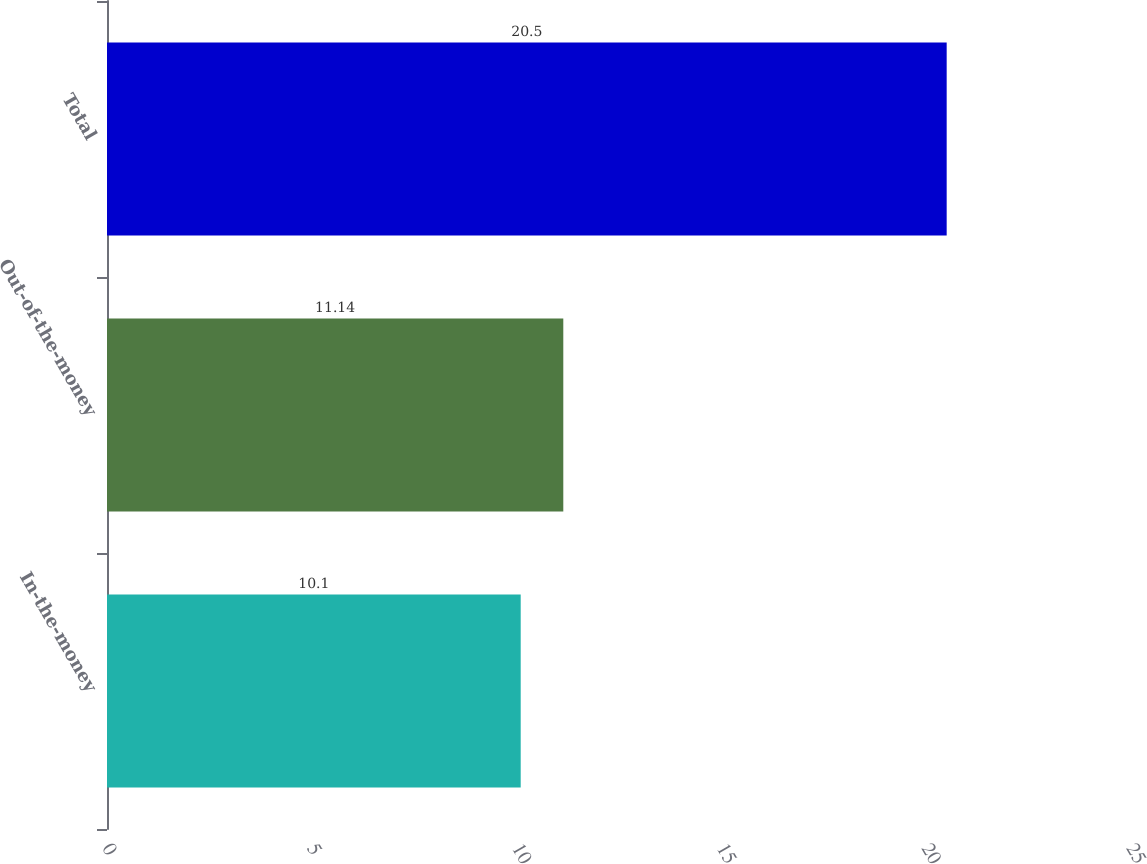Convert chart to OTSL. <chart><loc_0><loc_0><loc_500><loc_500><bar_chart><fcel>In-the-money<fcel>Out-of-the-money<fcel>Total<nl><fcel>10.1<fcel>11.14<fcel>20.5<nl></chart> 